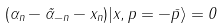Convert formula to latex. <formula><loc_0><loc_0><loc_500><loc_500>( \alpha _ { n } - \tilde { \alpha } _ { - n } - x _ { n } ) | x , p = - \bar { p } \rangle = 0</formula> 